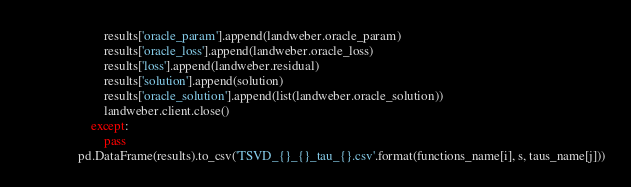Convert code to text. <code><loc_0><loc_0><loc_500><loc_500><_Python_>                        results['oracle_param'].append(landweber.oracle_param)
                        results['oracle_loss'].append(landweber.oracle_loss)
                        results['loss'].append(landweber.residual)
                        results['solution'].append(solution)
                        results['oracle_solution'].append(list(landweber.oracle_solution))
                        landweber.client.close()
                    except:
                        pass
                pd.DataFrame(results).to_csv('TSVD_{}_{}_tau_{}.csv'.format(functions_name[i], s, taus_name[j]))
</code> 